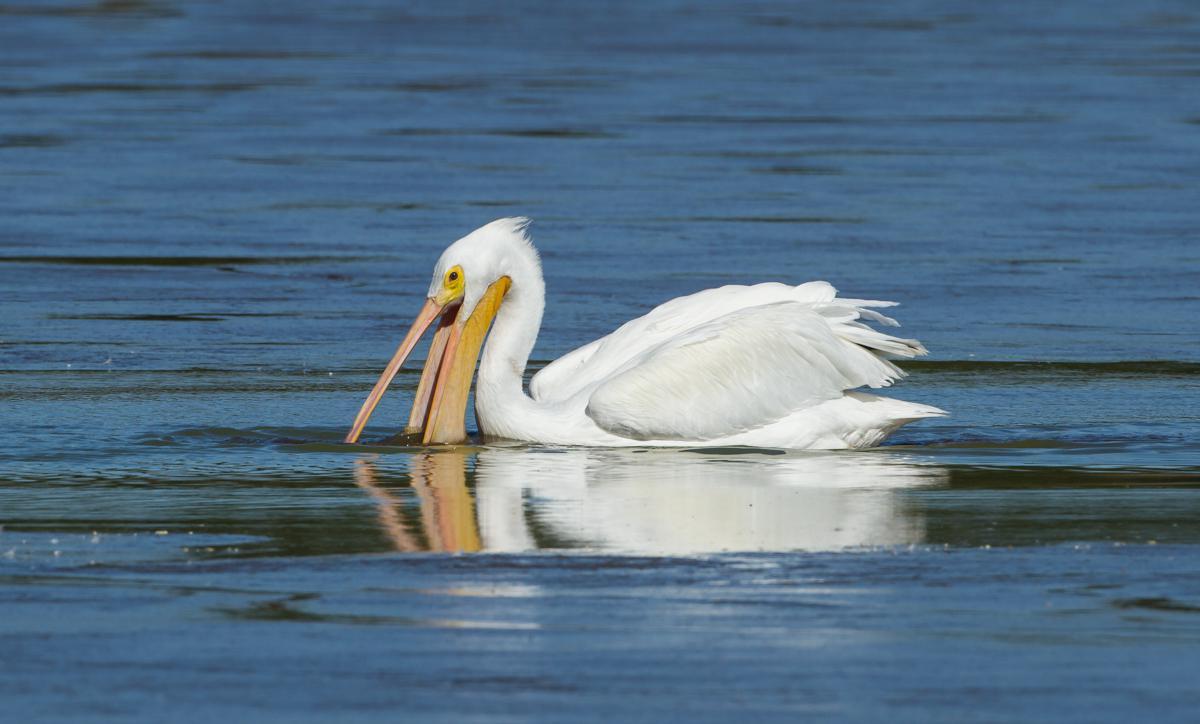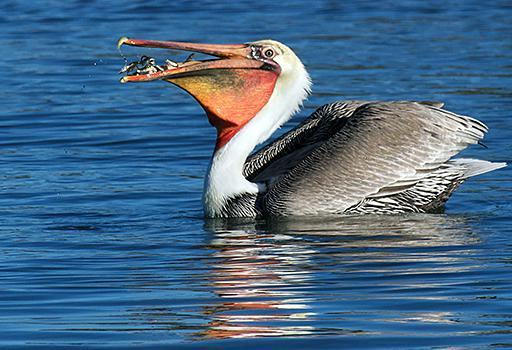The first image is the image on the left, the second image is the image on the right. Given the left and right images, does the statement "Each image shows a single pelican floating on water, and at least one image shows a fish in the bird's bill." hold true? Answer yes or no. Yes. The first image is the image on the left, the second image is the image on the right. For the images shown, is this caption "There is one human interacting with at least one bird in the left image." true? Answer yes or no. No. 